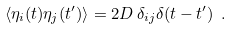Convert formula to latex. <formula><loc_0><loc_0><loc_500><loc_500>\langle \eta _ { i } ( t ) \eta _ { j } ( t ^ { \prime } ) \rangle = 2 D \, \delta _ { i j } \delta ( t - t ^ { \prime } ) \ .</formula> 